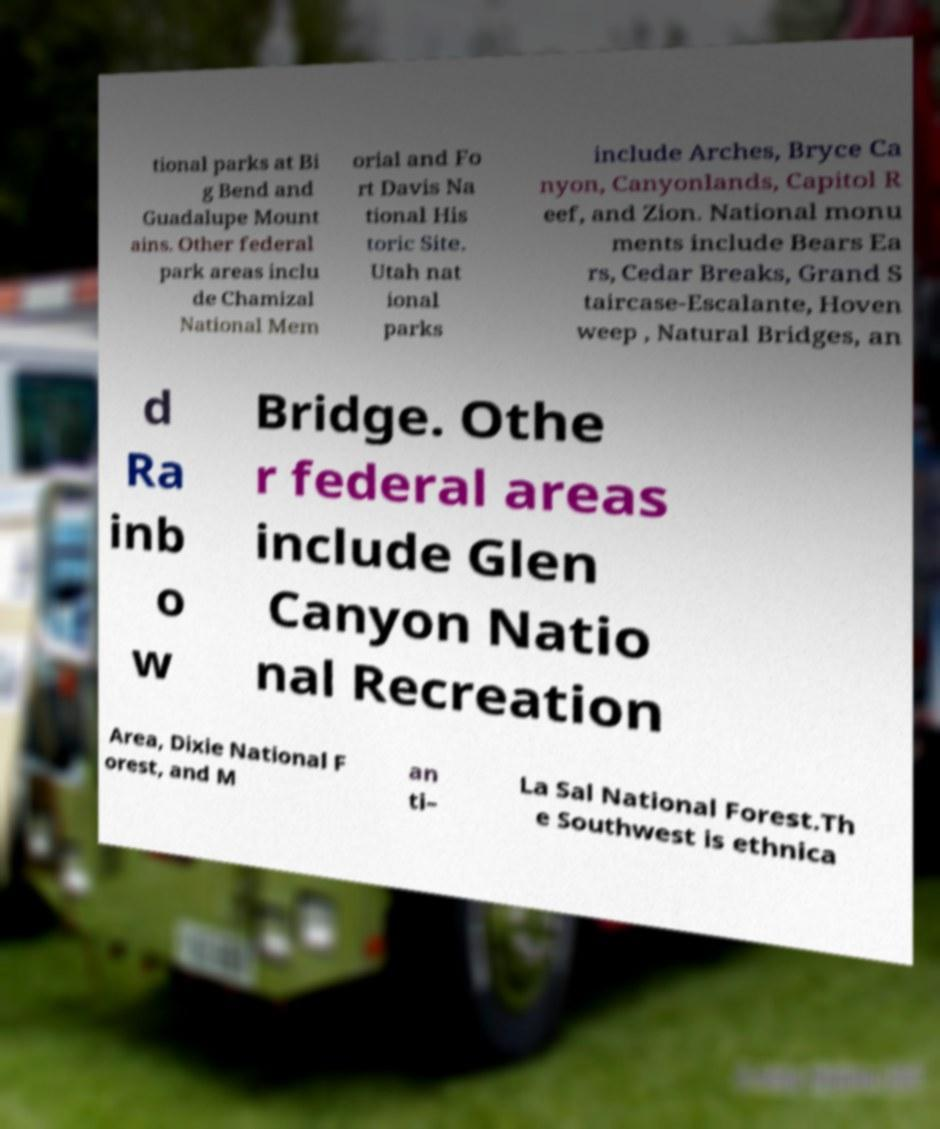There's text embedded in this image that I need extracted. Can you transcribe it verbatim? tional parks at Bi g Bend and Guadalupe Mount ains. Other federal park areas inclu de Chamizal National Mem orial and Fo rt Davis Na tional His toric Site. Utah nat ional parks include Arches, Bryce Ca nyon, Canyonlands, Capitol R eef, and Zion. National monu ments include Bears Ea rs, Cedar Breaks, Grand S taircase-Escalante, Hoven weep , Natural Bridges, an d Ra inb o w Bridge. Othe r federal areas include Glen Canyon Natio nal Recreation Area, Dixie National F orest, and M an ti– La Sal National Forest.Th e Southwest is ethnica 